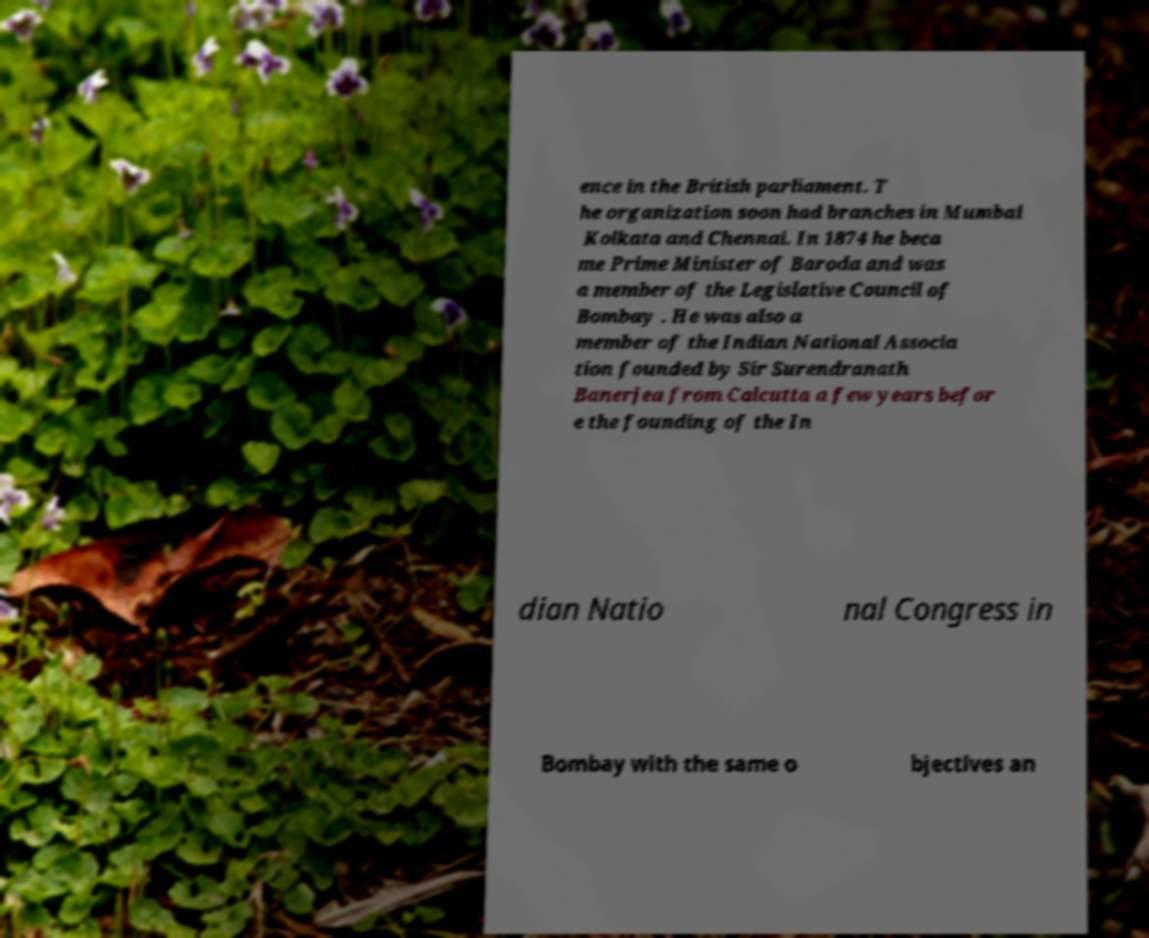Can you accurately transcribe the text from the provided image for me? ence in the British parliament. T he organization soon had branches in Mumbai Kolkata and Chennai. In 1874 he beca me Prime Minister of Baroda and was a member of the Legislative Council of Bombay . He was also a member of the Indian National Associa tion founded by Sir Surendranath Banerjea from Calcutta a few years befor e the founding of the In dian Natio nal Congress in Bombay with the same o bjectives an 